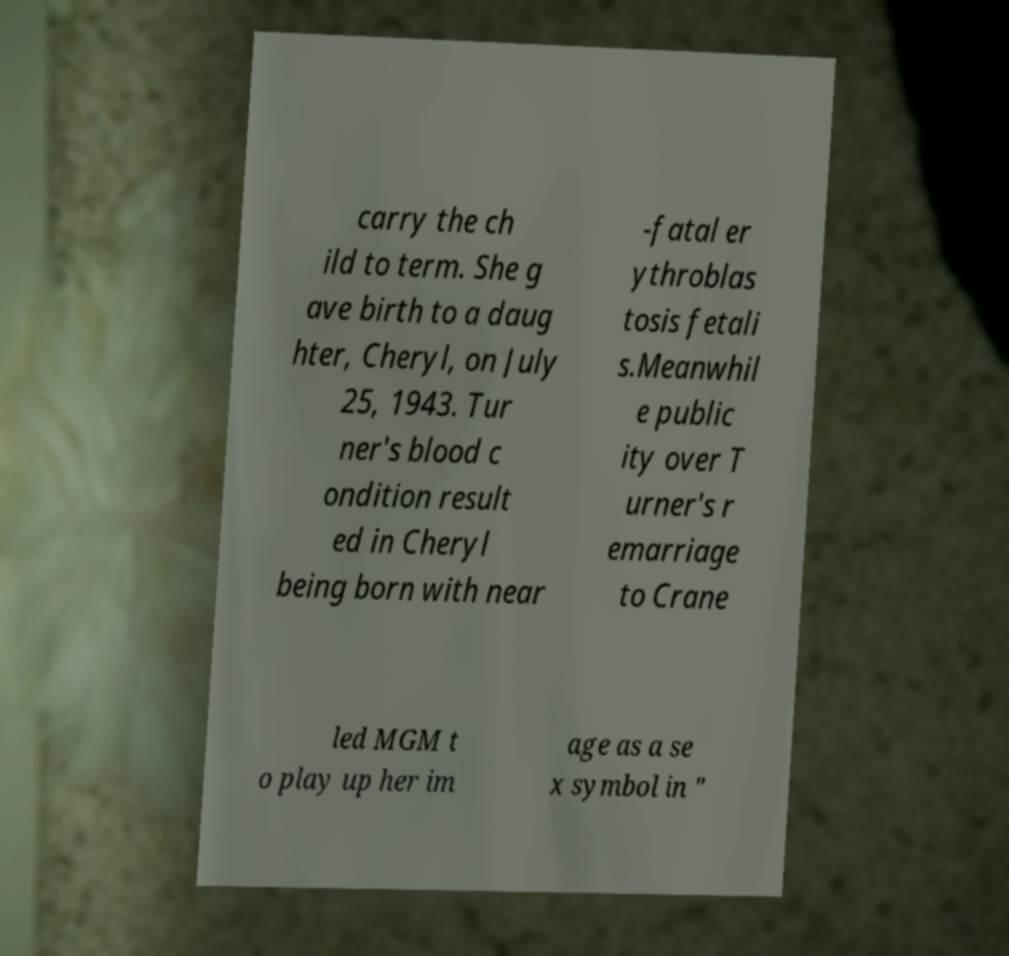Could you extract and type out the text from this image? carry the ch ild to term. She g ave birth to a daug hter, Cheryl, on July 25, 1943. Tur ner's blood c ondition result ed in Cheryl being born with near -fatal er ythroblas tosis fetali s.Meanwhil e public ity over T urner's r emarriage to Crane led MGM t o play up her im age as a se x symbol in " 